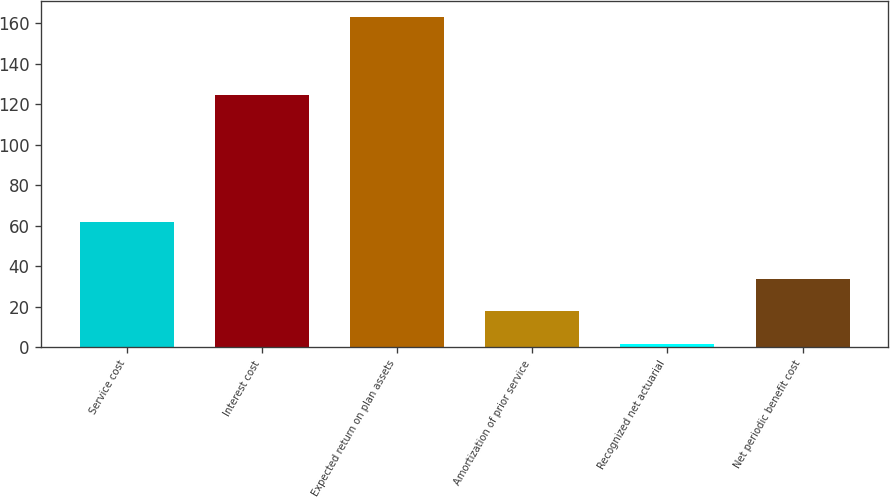Convert chart to OTSL. <chart><loc_0><loc_0><loc_500><loc_500><bar_chart><fcel>Service cost<fcel>Interest cost<fcel>Expected return on plan assets<fcel>Amortization of prior service<fcel>Recognized net actuarial<fcel>Net periodic benefit cost<nl><fcel>62<fcel>124.3<fcel>162.8<fcel>17.63<fcel>1.5<fcel>33.76<nl></chart> 